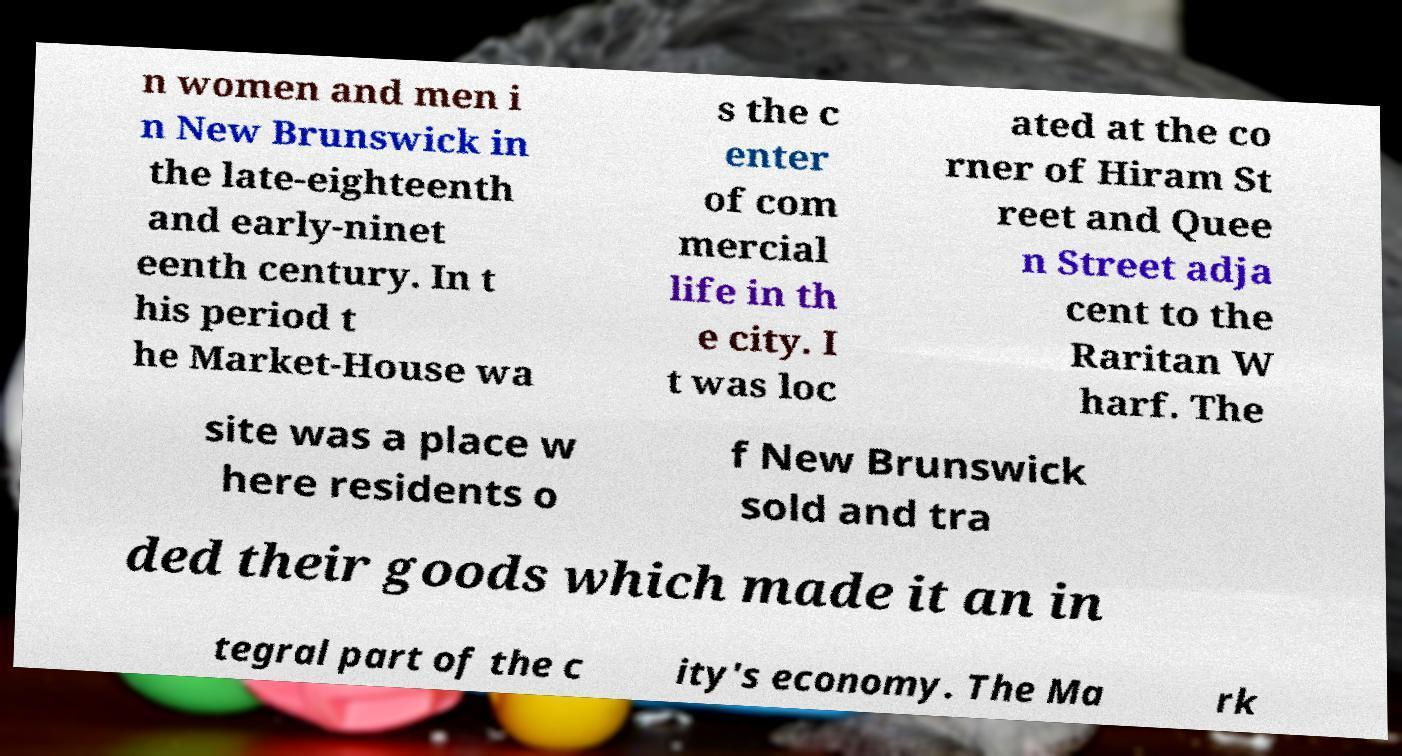For documentation purposes, I need the text within this image transcribed. Could you provide that? n women and men i n New Brunswick in the late-eighteenth and early-ninet eenth century. In t his period t he Market-House wa s the c enter of com mercial life in th e city. I t was loc ated at the co rner of Hiram St reet and Quee n Street adja cent to the Raritan W harf. The site was a place w here residents o f New Brunswick sold and tra ded their goods which made it an in tegral part of the c ity's economy. The Ma rk 